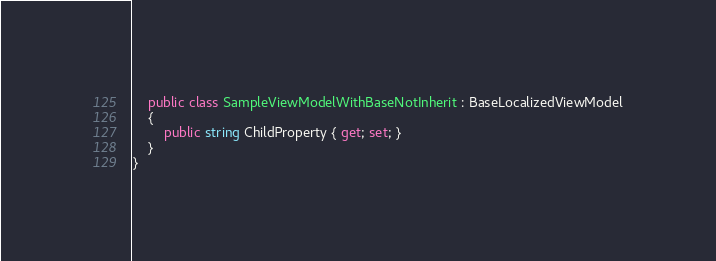Convert code to text. <code><loc_0><loc_0><loc_500><loc_500><_C#_>    public class SampleViewModelWithBaseNotInherit : BaseLocalizedViewModel
    {
        public string ChildProperty { get; set; }
    }
}
</code> 